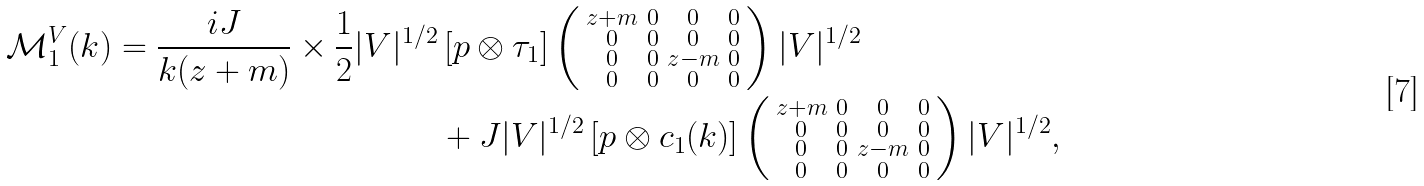Convert formula to latex. <formula><loc_0><loc_0><loc_500><loc_500>\mathcal { M } _ { 1 } ^ { V } ( k ) = \frac { i J } { k ( z + m ) } \times \frac { 1 } { 2 } | V | ^ { 1 / 2 } & \left [ p \otimes \tau _ { 1 } \right ] \left ( \begin{smallmatrix} z + m & 0 & 0 & 0 \\ 0 & 0 & 0 & 0 \\ 0 & 0 & z - m & 0 \\ 0 & 0 & 0 & 0 \end{smallmatrix} \right ) | V | ^ { 1 / 2 } \\ & + J | V | ^ { 1 / 2 } \left [ p \otimes c _ { 1 } ( k ) \right ] \left ( \begin{smallmatrix} z + m & 0 & 0 & 0 \\ 0 & 0 & 0 & 0 \\ 0 & 0 & z - m & 0 \\ 0 & 0 & 0 & 0 \end{smallmatrix} \right ) | V | ^ { 1 / 2 } ,</formula> 